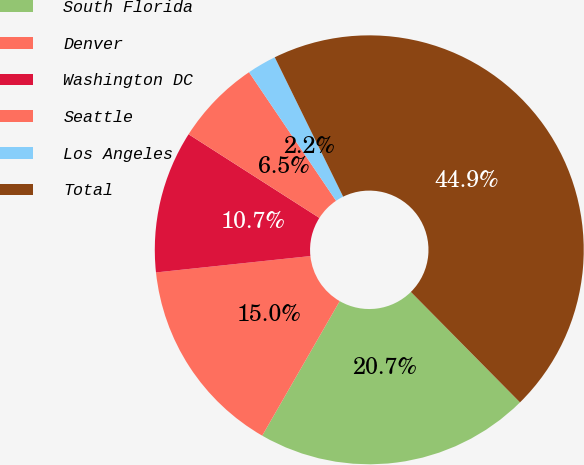Convert chart. <chart><loc_0><loc_0><loc_500><loc_500><pie_chart><fcel>South Florida<fcel>Denver<fcel>Washington DC<fcel>Seattle<fcel>Los Angeles<fcel>Total<nl><fcel>20.72%<fcel>15.0%<fcel>10.74%<fcel>6.47%<fcel>2.21%<fcel>44.86%<nl></chart> 